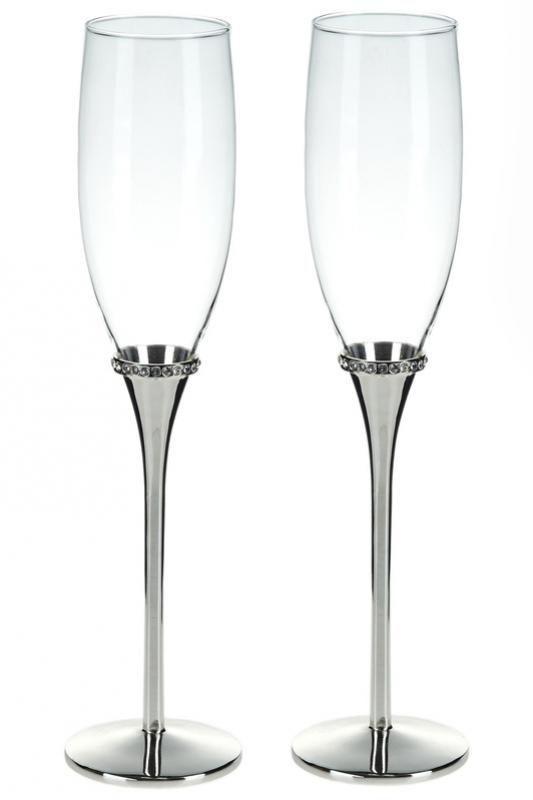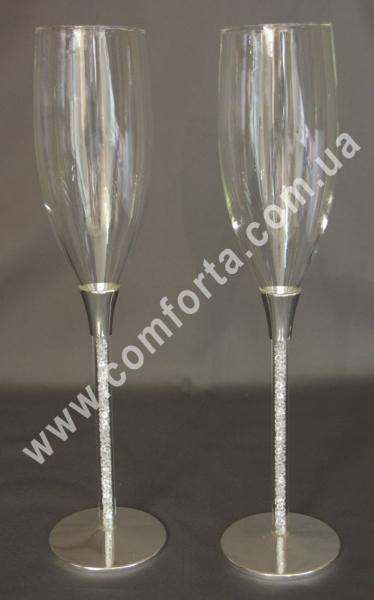The first image is the image on the left, the second image is the image on the right. Considering the images on both sides, is "There are four clear glasses with silver stems." valid? Answer yes or no. Yes. The first image is the image on the left, the second image is the image on the right. Analyze the images presented: Is the assertion "There are four champagne flutes with silver bases." valid? Answer yes or no. Yes. 